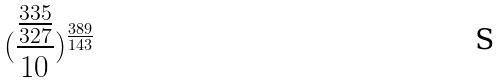<formula> <loc_0><loc_0><loc_500><loc_500>( \frac { \frac { 3 3 5 } { 3 2 7 } } { 1 0 } ) ^ { \frac { 3 8 9 } { 1 4 3 } }</formula> 